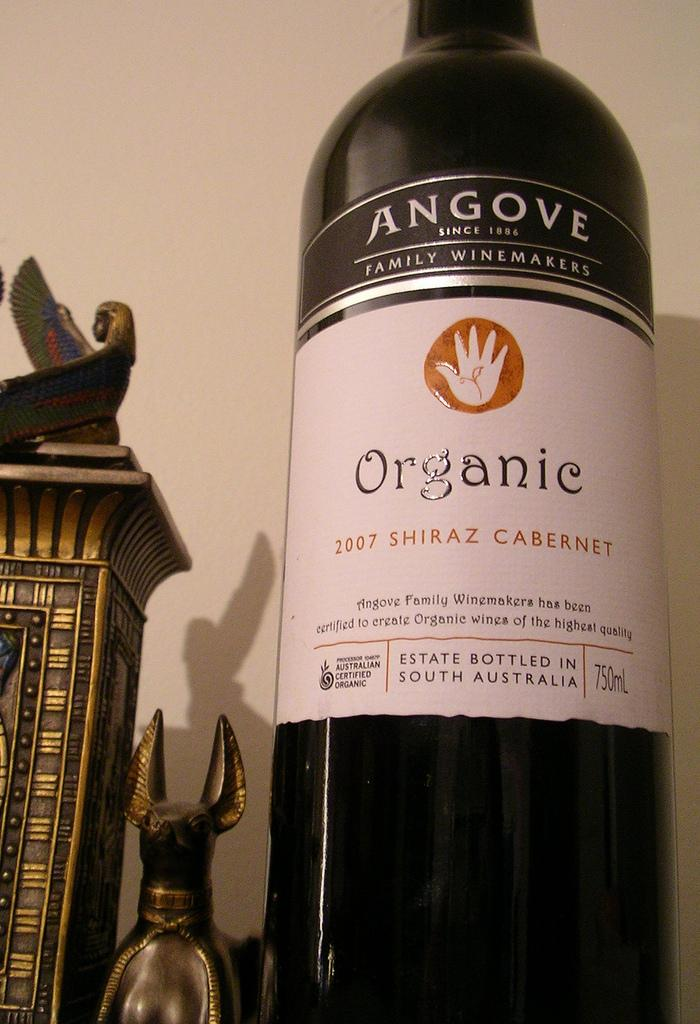What is located on the right side of the image? There is a bottle on the right side of the image. What can be seen on the left side of the image? There are objects on the left side of the image. What is visible in the background of the image? The wall is in the background of the image. How many beads are in the basket on the left side of the image? There is no basket or beads present in the image. What type of lift is visible in the image? There is no lift present in the image. 